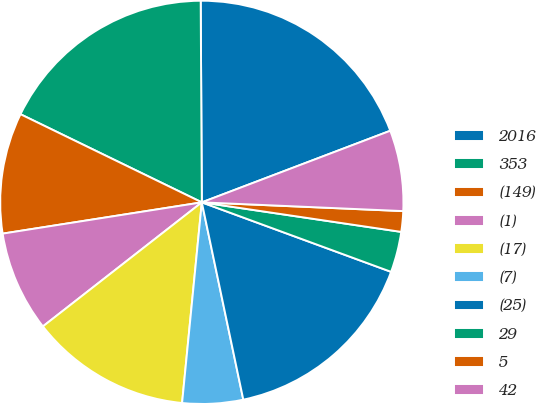Convert chart to OTSL. <chart><loc_0><loc_0><loc_500><loc_500><pie_chart><fcel>2016<fcel>353<fcel>(149)<fcel>(1)<fcel>(17)<fcel>(7)<fcel>(25)<fcel>29<fcel>5<fcel>42<nl><fcel>19.31%<fcel>17.71%<fcel>9.68%<fcel>8.07%<fcel>12.89%<fcel>4.86%<fcel>16.1%<fcel>3.26%<fcel>1.65%<fcel>6.47%<nl></chart> 